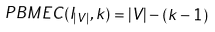Convert formula to latex. <formula><loc_0><loc_0><loc_500><loc_500>P B M E C ( I _ { | V | } , k ) = | V | - ( k - 1 )</formula> 